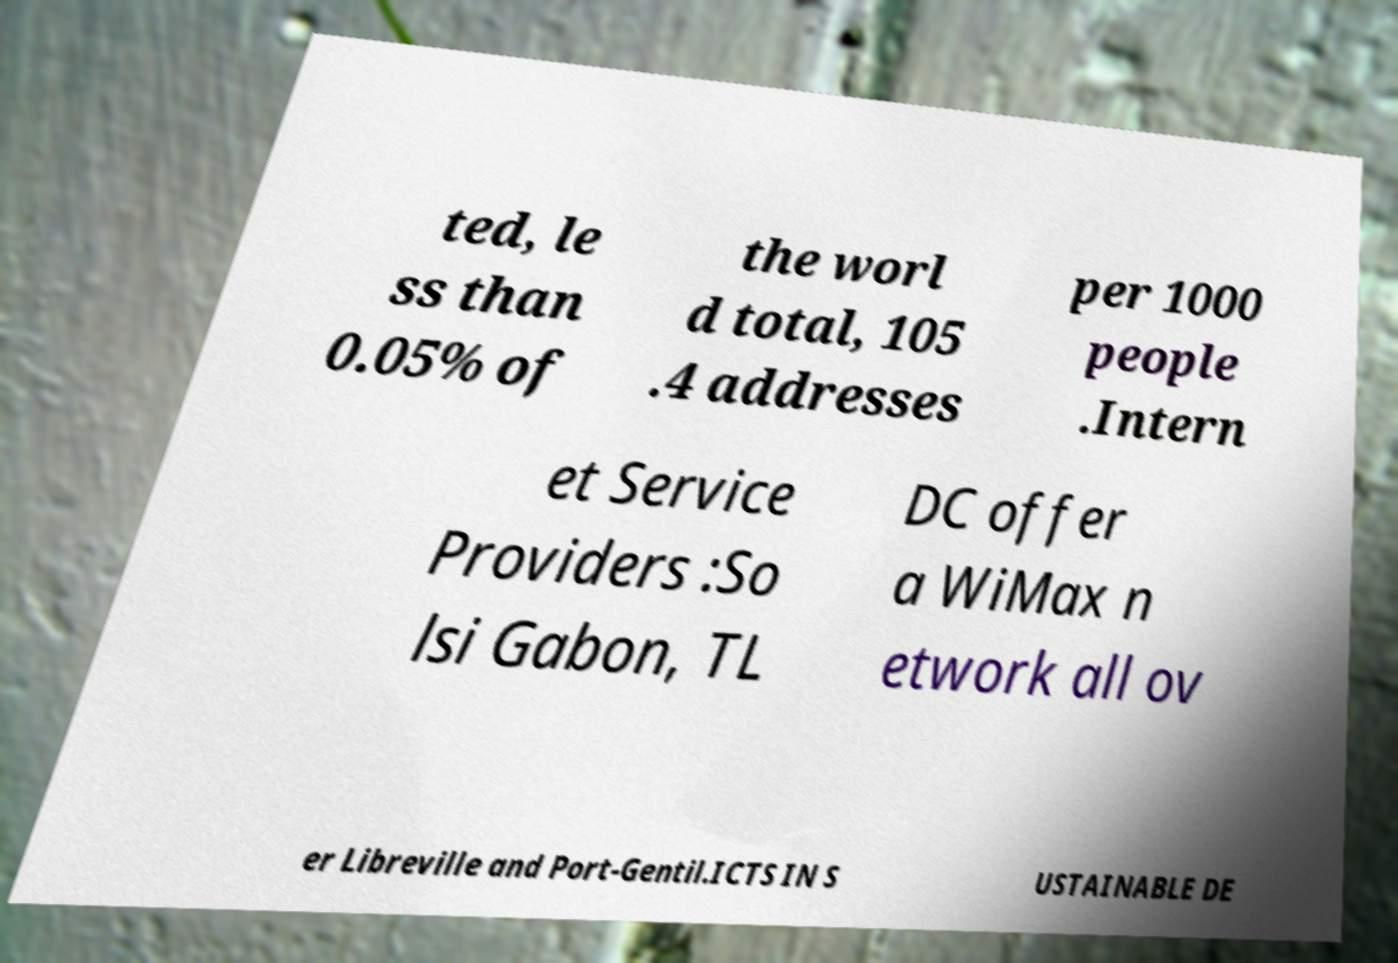Can you accurately transcribe the text from the provided image for me? ted, le ss than 0.05% of the worl d total, 105 .4 addresses per 1000 people .Intern et Service Providers :So lsi Gabon, TL DC offer a WiMax n etwork all ov er Libreville and Port-Gentil.ICTS IN S USTAINABLE DE 